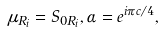Convert formula to latex. <formula><loc_0><loc_0><loc_500><loc_500>\mu _ { R _ { i } } = S _ { 0 R _ { i } } , \alpha = e ^ { i \pi c / 4 } ,</formula> 